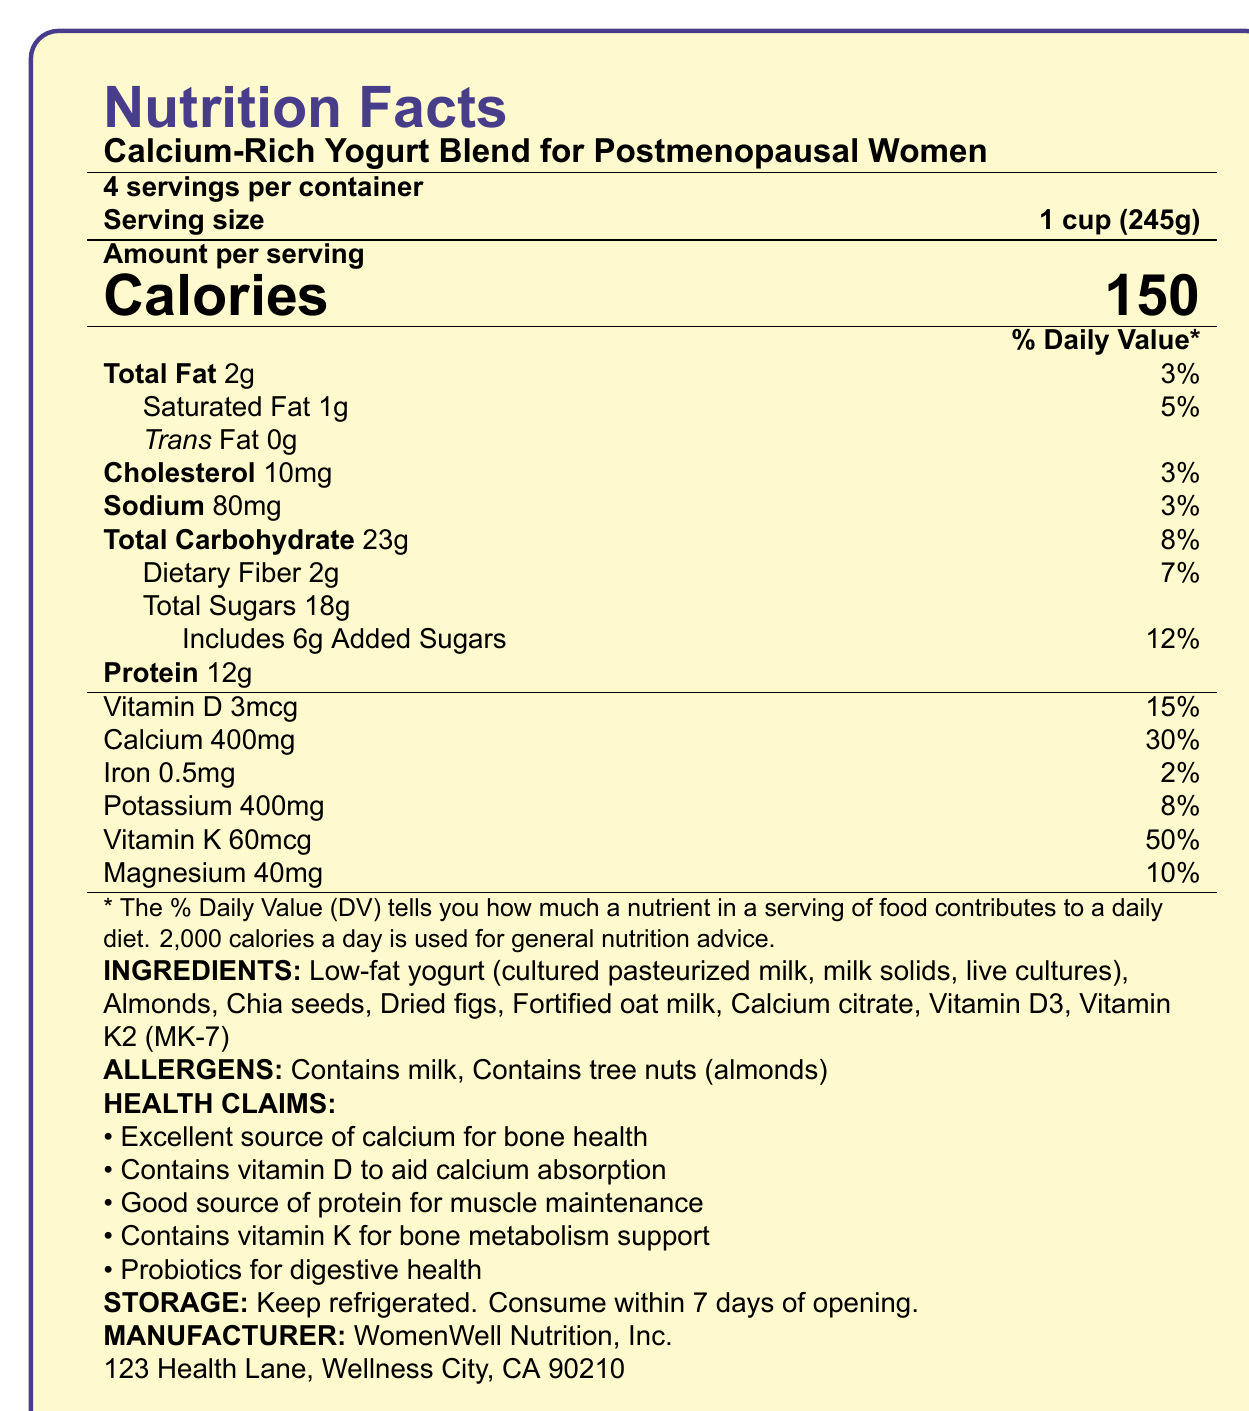What is the serving size of the product? The document specifies that the serving size is 1 cup, which is equivalent to 245 grams.
Answer: 1 cup (245g) How many calories are there in one serving? The document clearly states that each serving contains 150 calories.
Answer: 150 What percentage of the daily value is the calcium content per serving? The document indicates that each serving provides 400mg of calcium, which is 30% of the daily value.
Answer: 30% List two allergens present in this product. Under the allergens section, the document states that the product contains milk and tree nuts (almonds).
Answer: Milk, Almonds How long should you consume the product after opening it? The storage instructions on the document indicate that the product should be consumed within 7 days of opening.
Answer: Within 7 days Which vitamin in this product supports bone metabolism? A. Vitamin D B. Vitamin K2 C. Vitamin C D. Vitamin B12 The health claims section of the document states that the product contains vitamin K for bone metabolism support.
Answer: B. Vitamin K2 How much protein is in one serving? A. 10g B. 12g C. 15g D. 8g It is stated in the document that each serving contains 12g of protein.
Answer: B. 12g Does this product contain trans fat? The document lists trans fat as 0g, indicating that there is no trans fat in the product.
Answer: No Is this product a good source of fiber? The product contains 2g of dietary fiber per serving, which constitutes 7% of the daily value.
Answer: Yes Summarize the main nutritional benefits of this product. The document highlights various nutritional benefits of the product, particularly its contributions to bone health and digestive health through its high calcium, vitamin D, vitamin K, and probiotic content.
Answer: This product is a calcium-rich yogurt blend designed for postmenopausal women. It provides significant amounts of calcium (30% DV), vitamin D (15% DV), and vitamin K (50% DV) for bone health. It is also a good source of protein (12g per serving) and contains probiotics for digestive health. How many servings are there in the entire container? The document specifies that there are 4 servings per container.
Answer: 4 Which ingredient provides live cultures to the yogurt? The ingredients list mentions that the low-fat yogurt contains cultured pasteurized milk, milk solids, and live cultures.
Answer: Low-fat yogurt (cultured pasteurized milk, milk solids, live cultures) What is the daily value percentage of magnesium in this product? The document lists magnesium content as 40mg, which is 10% of the daily value.
Answer: 10% Can you determine the exact amount of Vitamin K provided in one serving? The document does not specify the daily recommended value for Vitamin K, so without that baseline, we cannot precisely calculate the exact amount.
Answer: Not enough information What should you do to store this product properly? The storage instructions specify that the product should be kept refrigerated.
Answer: Keep refrigerated. 